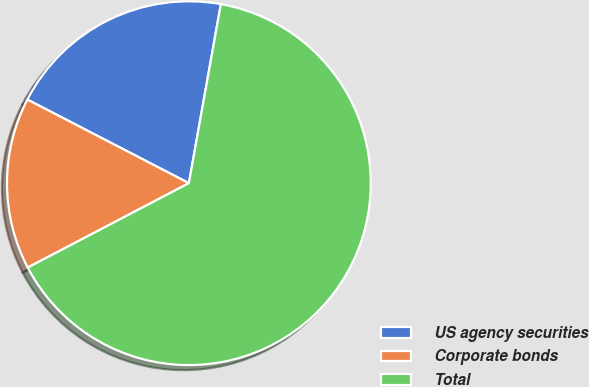Convert chart. <chart><loc_0><loc_0><loc_500><loc_500><pie_chart><fcel>US agency securities<fcel>Corporate bonds<fcel>Total<nl><fcel>20.21%<fcel>15.28%<fcel>64.51%<nl></chart> 